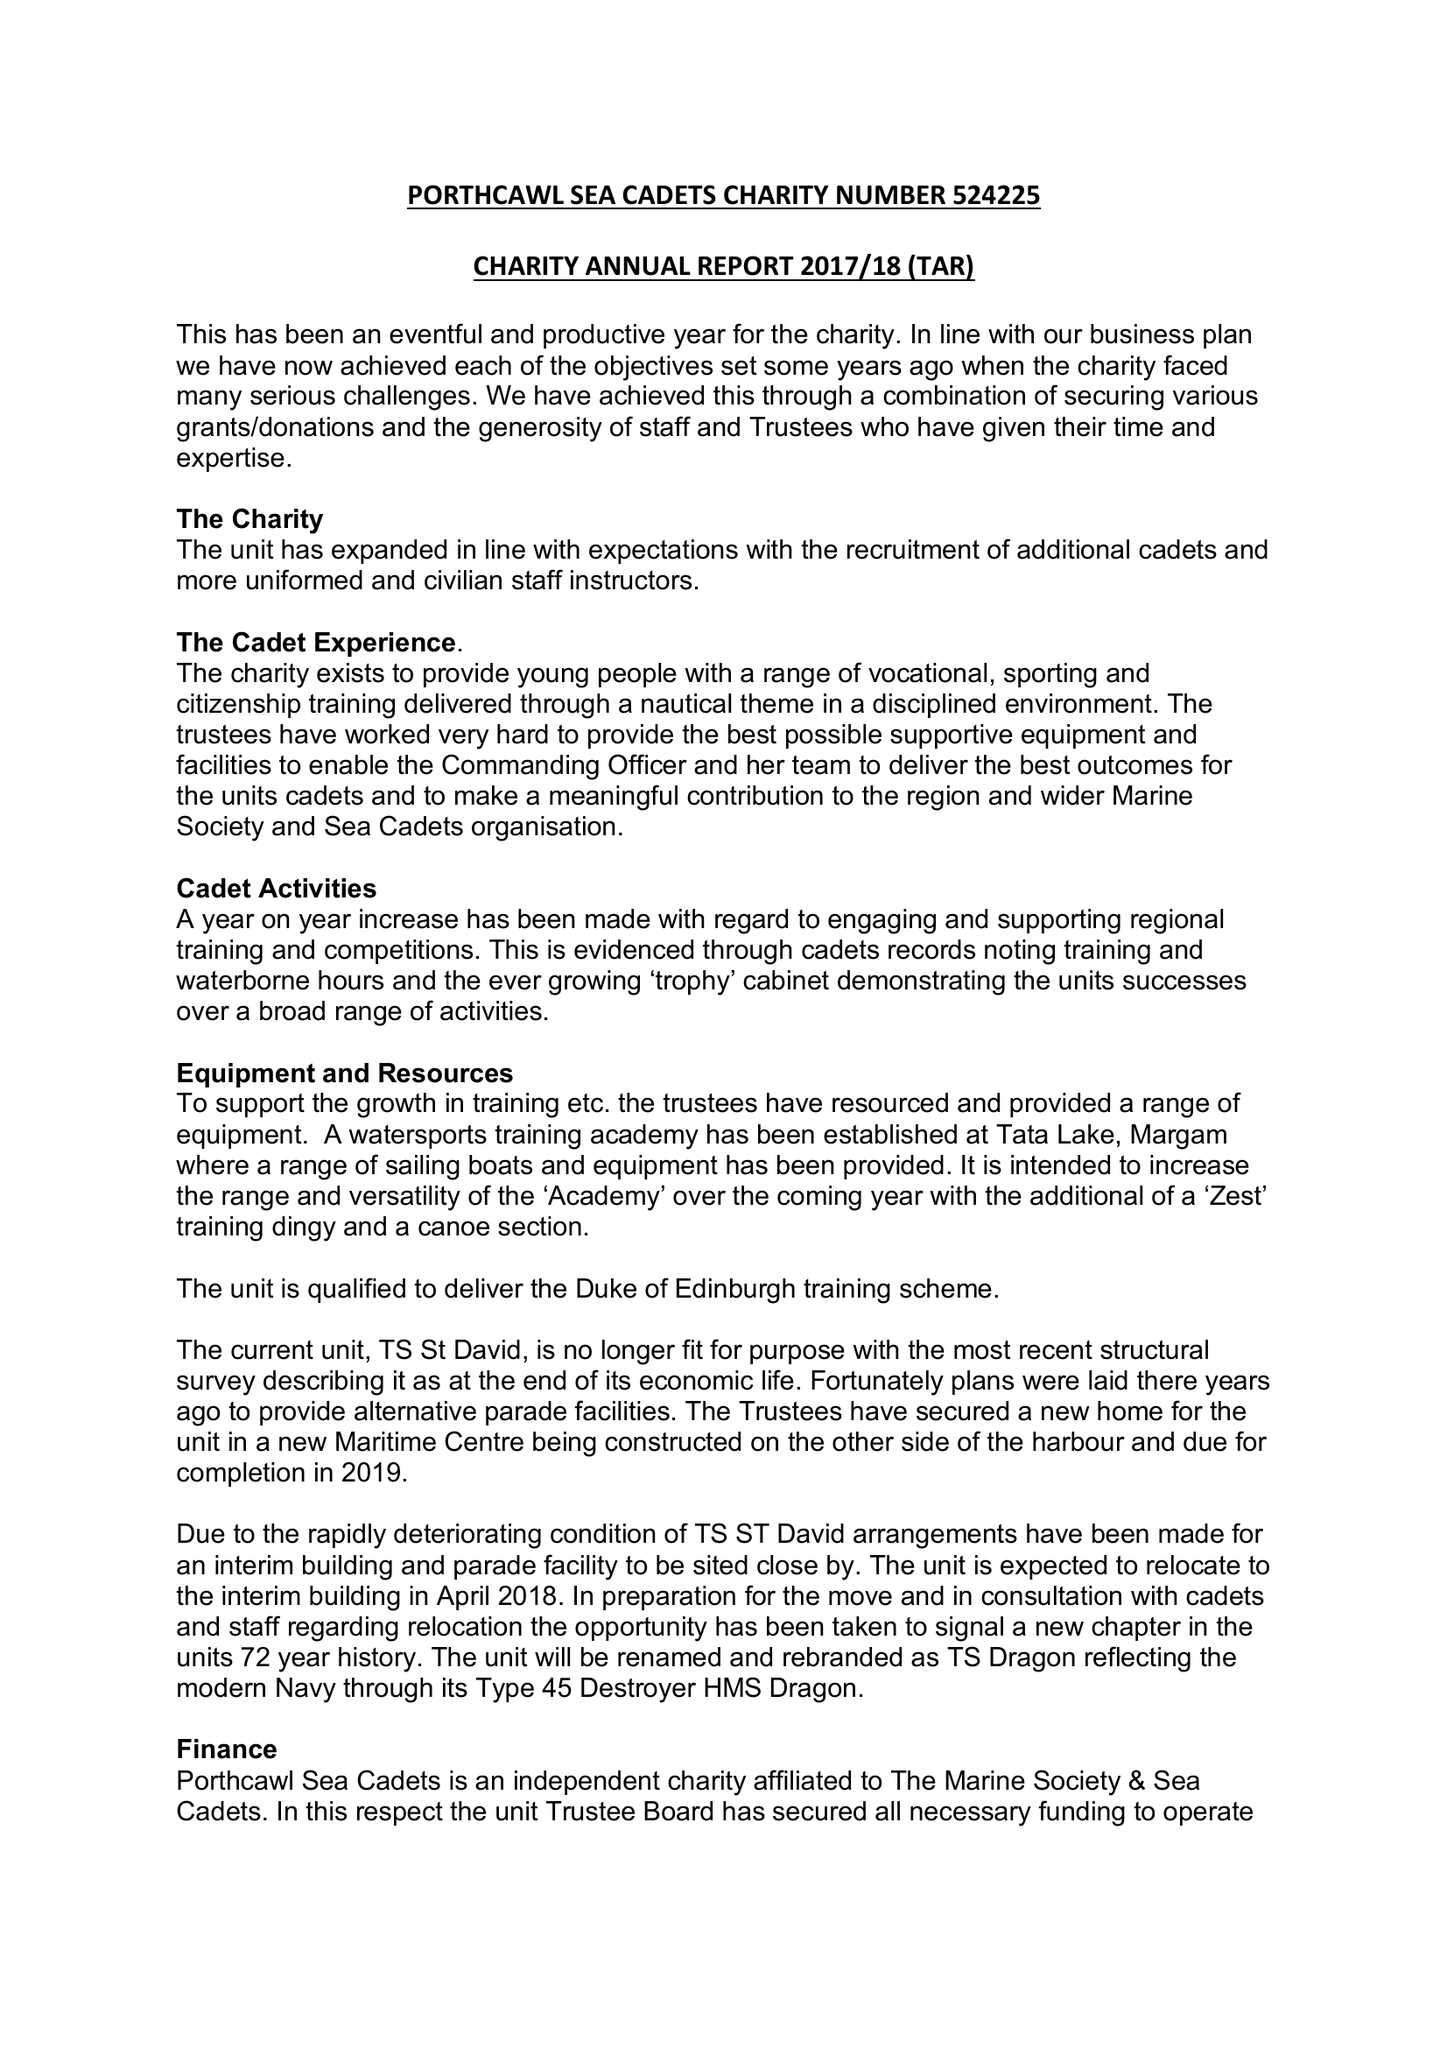What is the value for the income_annually_in_british_pounds?
Answer the question using a single word or phrase. 66688.22 